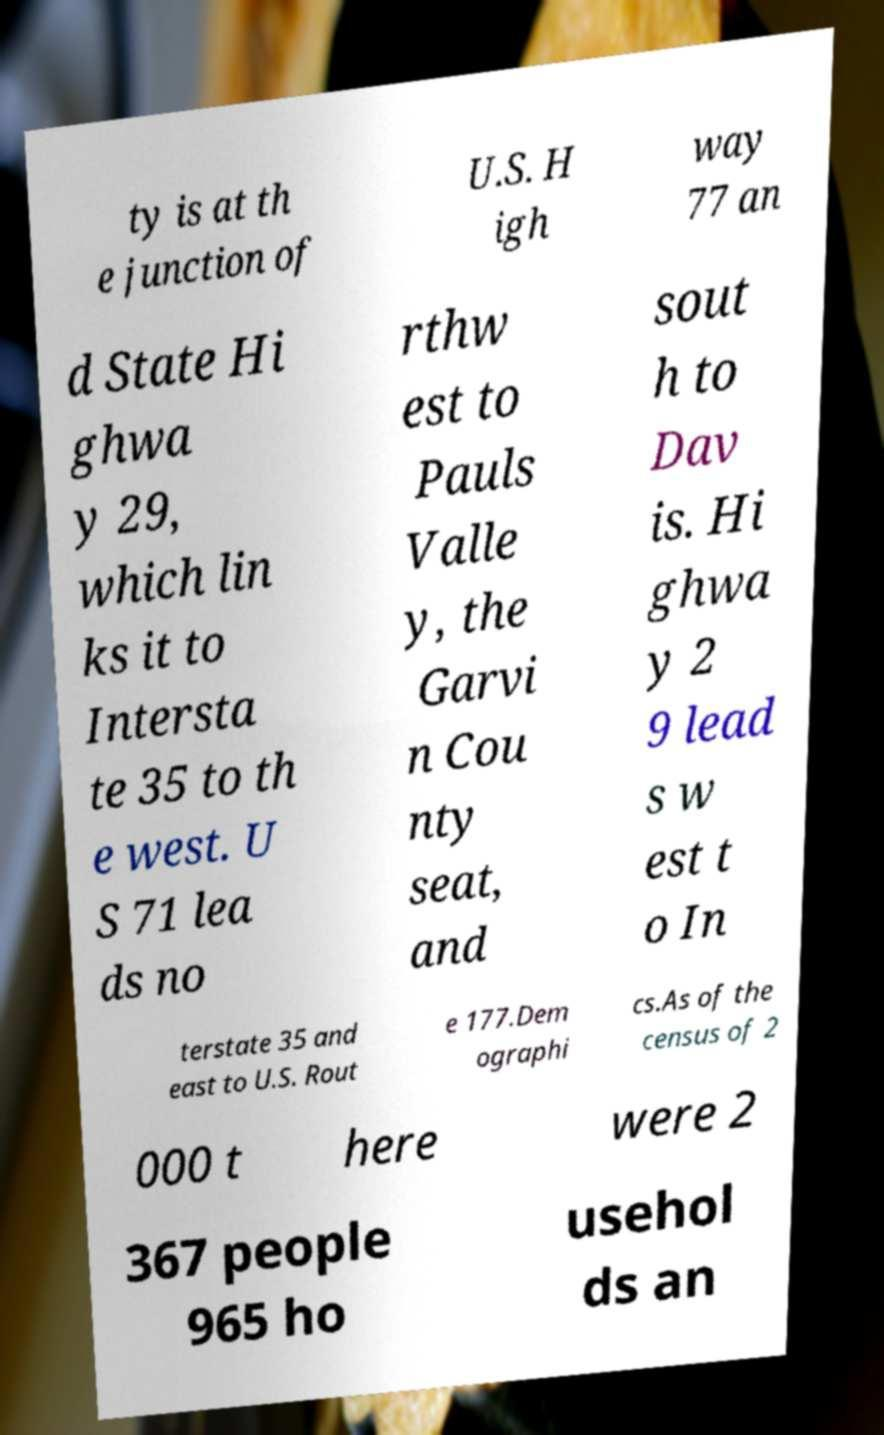Can you accurately transcribe the text from the provided image for me? ty is at th e junction of U.S. H igh way 77 an d State Hi ghwa y 29, which lin ks it to Intersta te 35 to th e west. U S 71 lea ds no rthw est to Pauls Valle y, the Garvi n Cou nty seat, and sout h to Dav is. Hi ghwa y 2 9 lead s w est t o In terstate 35 and east to U.S. Rout e 177.Dem ographi cs.As of the census of 2 000 t here were 2 367 people 965 ho usehol ds an 